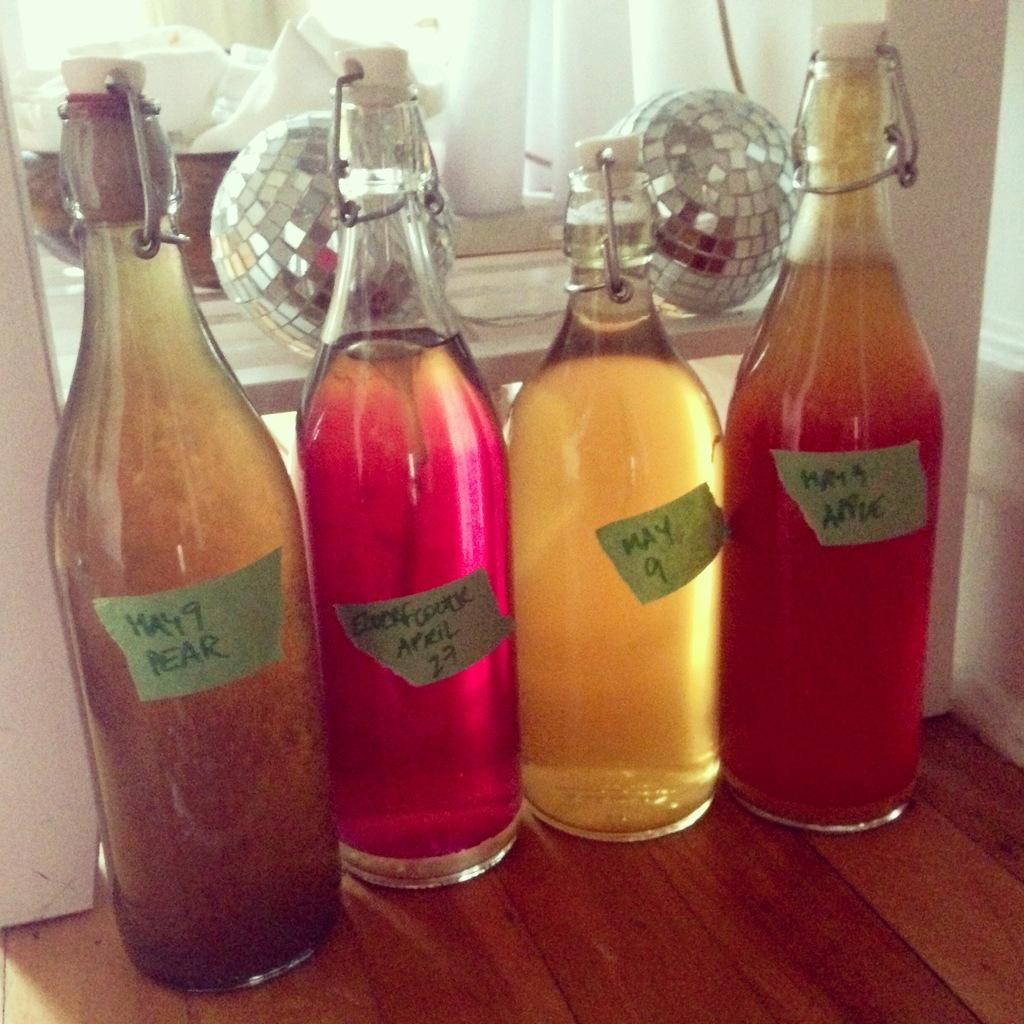<image>
Give a short and clear explanation of the subsequent image. A bottle with a piece of tape on it that says May 9 Pear is next to three other bottles. 